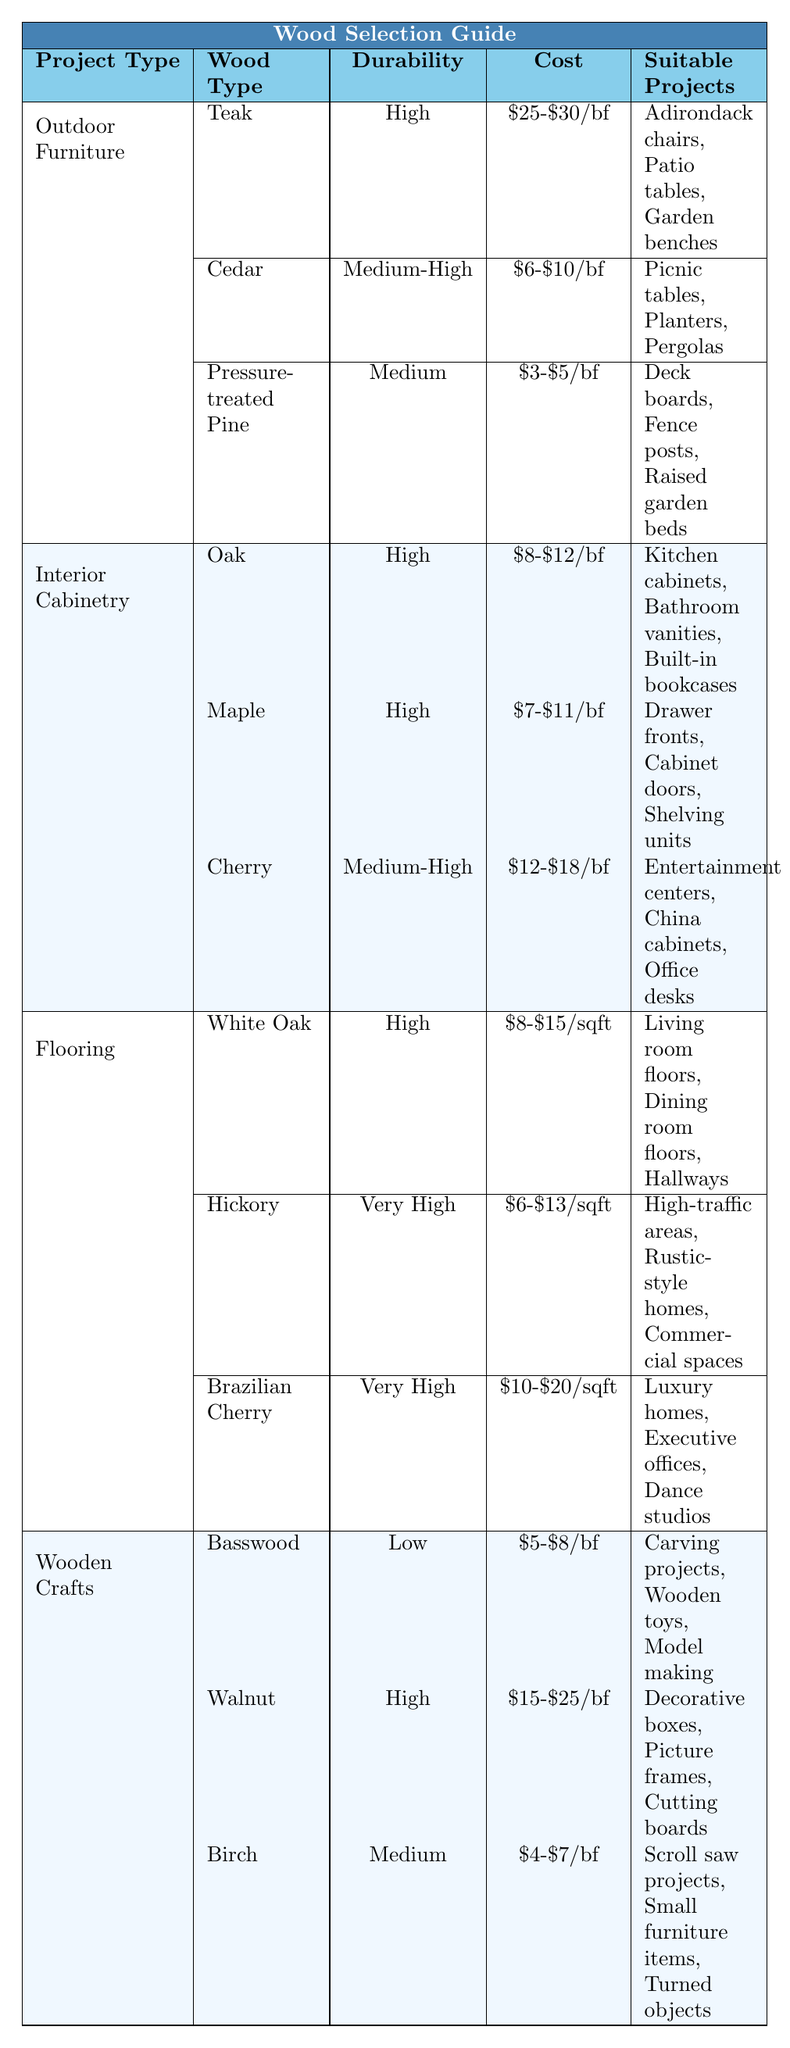What wood type is recommended for Adirondack chairs? From the table under the section "Outdoor Furniture," Teak is listed as a suitable wood type for Adirondack chairs.
Answer: Teak What is the cost range for Cedar per board foot? The table shows that Cedar has a cost range of $6 to $10 per board foot.
Answer: $6-$10 Is Birch a good choice for high-durability projects? The table indicates that Birch has a durability rating of Medium, which suggests it is not suitable for high-durability projects.
Answer: No What is the most expensive wood type recommended for wooden crafts? According to the table, Walnut has the highest cost range at $15 to $25 per board foot among the wooden crafts.
Answer: Walnut For indoor cabinetry, which wood has the lowest cost per board foot? The costs listed for oak, maple, and cherry show that the lowest cost per board foot is for maple, at $7 to $11.
Answer: Maple How many wood types are suitable for flooring projects? The table lists three wood types for flooring: White Oak, Hickory, and Brazilian Cherry, making a total of three.
Answer: 3 Are there any woods recommended for both outdoor furniture and flooring? The table documents separate wood types for each category, indicating that no wood types are repeated in both categories.
Answer: No What is the average durability rating for woods used in wooden crafts? The durability ratings for Basswood, Walnut, and Birch are Low, High, and Medium respectively. To find the average, we can assign numerical values (Low=1, Medium=2, High=3) and calculate: (1 + 3 + 2) / 3 = 2. Therefore, the average durability rating is Medium.
Answer: Medium Which wood is the cheapest per board foot among those listed for outdoor furniture? The table shows that Pressure-treated Pine costs between $3 to $5 per board foot, which is the lowest compared to other outdoor options.
Answer: Pressure-treated Pine Which wood types can be used for decorative boxes? Walnut is the designated wood type for making decorative boxes, based on the wooden crafts section of the table.
Answer: Walnut What wood type is suitable for high-traffic areas? Hickory is noted as the recommended wood type for high-traffic areas in the flooring section of the table.
Answer: Hickory 